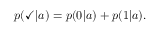Convert formula to latex. <formula><loc_0><loc_0><loc_500><loc_500>p ( \check { m } a r k | a ) = p ( 0 | a ) + p ( 1 | a ) .</formula> 